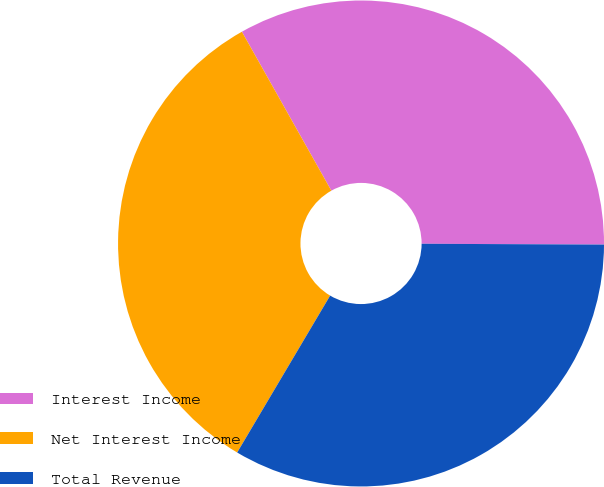Convert chart. <chart><loc_0><loc_0><loc_500><loc_500><pie_chart><fcel>Interest Income<fcel>Net Interest Income<fcel>Total Revenue<nl><fcel>33.23%<fcel>33.33%<fcel>33.44%<nl></chart> 